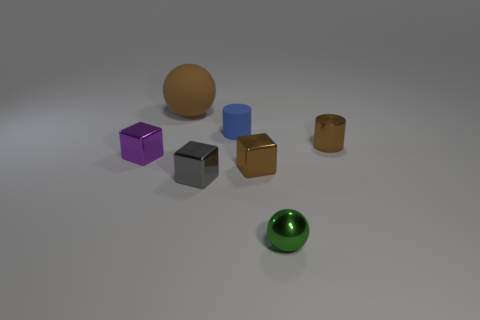Subtract all blue balls. Subtract all blue cubes. How many balls are left? 2 Add 1 tiny cyan cylinders. How many objects exist? 8 Subtract all spheres. How many objects are left? 5 Add 6 tiny matte cubes. How many tiny matte cubes exist? 6 Subtract 0 cyan balls. How many objects are left? 7 Subtract all large brown spheres. Subtract all gray metallic objects. How many objects are left? 5 Add 4 big brown matte objects. How many big brown matte objects are left? 5 